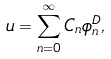<formula> <loc_0><loc_0><loc_500><loc_500>u = \sum _ { n = 0 } ^ { \infty } C _ { n } \phi _ { n } ^ { D } ,</formula> 